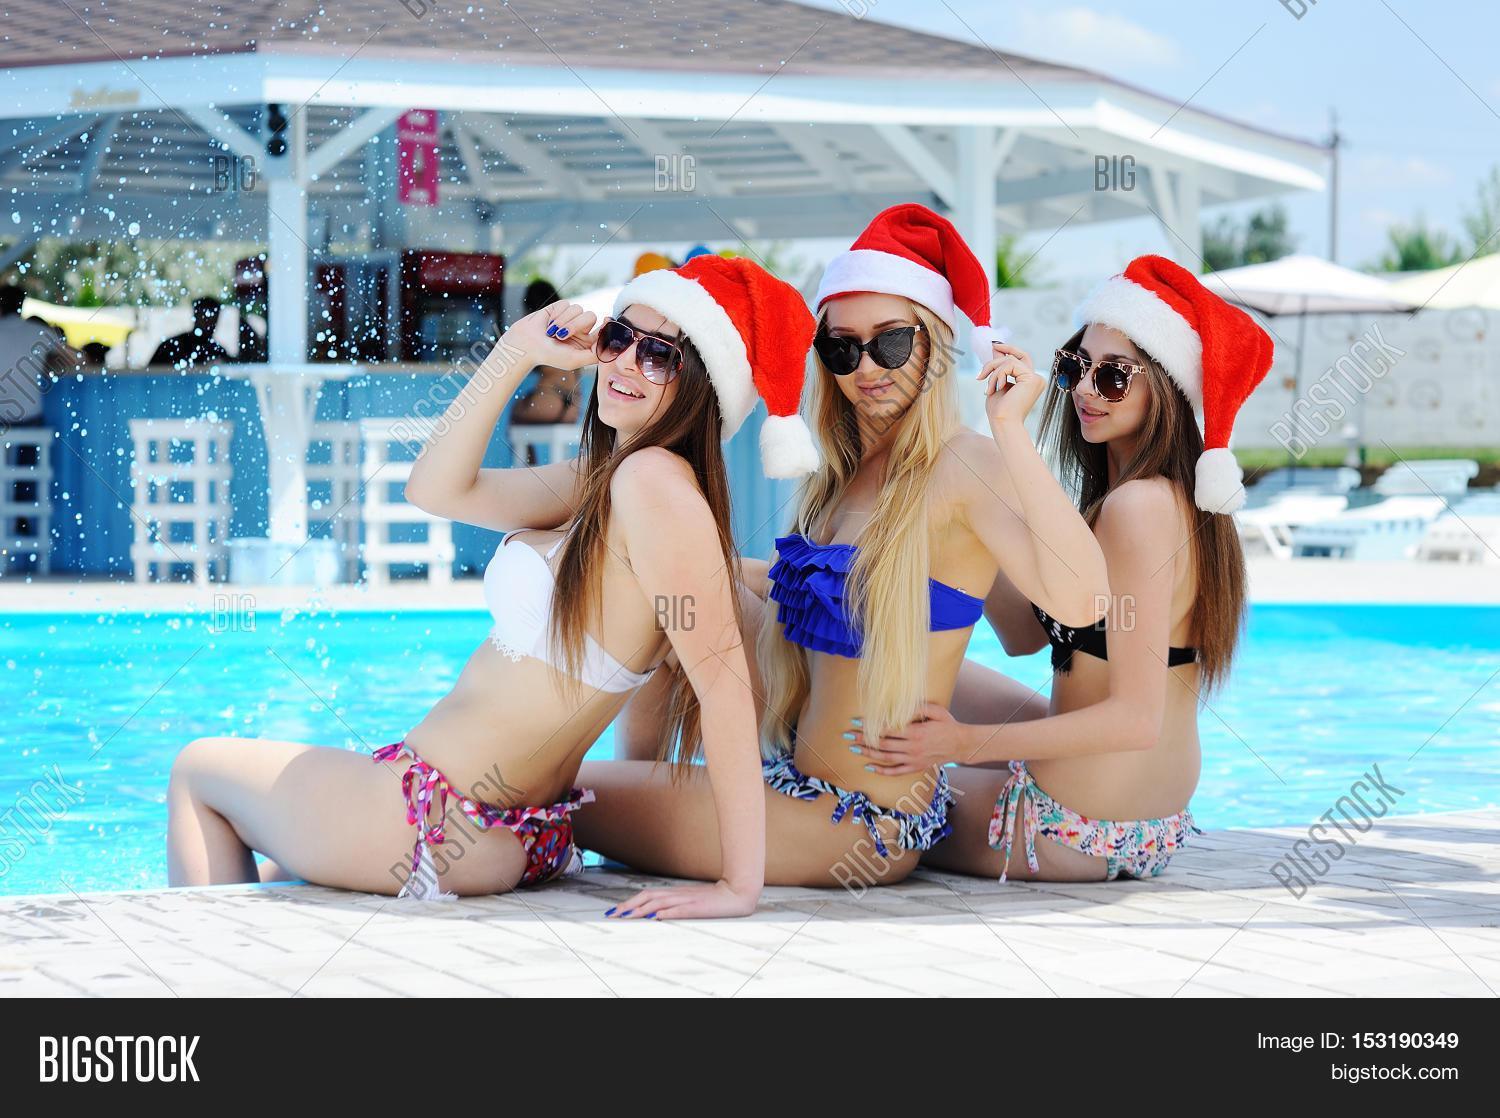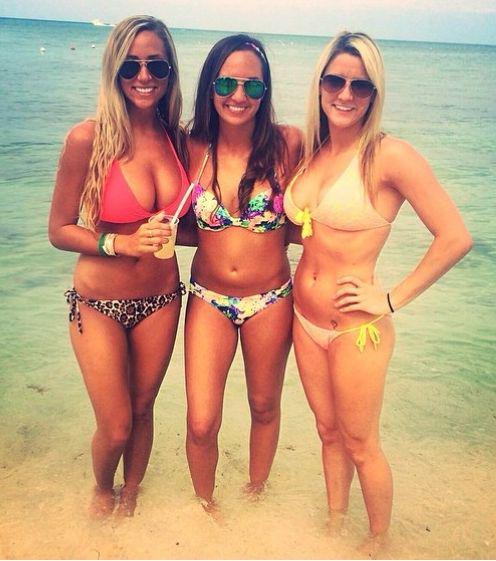The first image is the image on the left, the second image is the image on the right. Analyze the images presented: Is the assertion "There are six women wearing swimsuits." valid? Answer yes or no. Yes. 